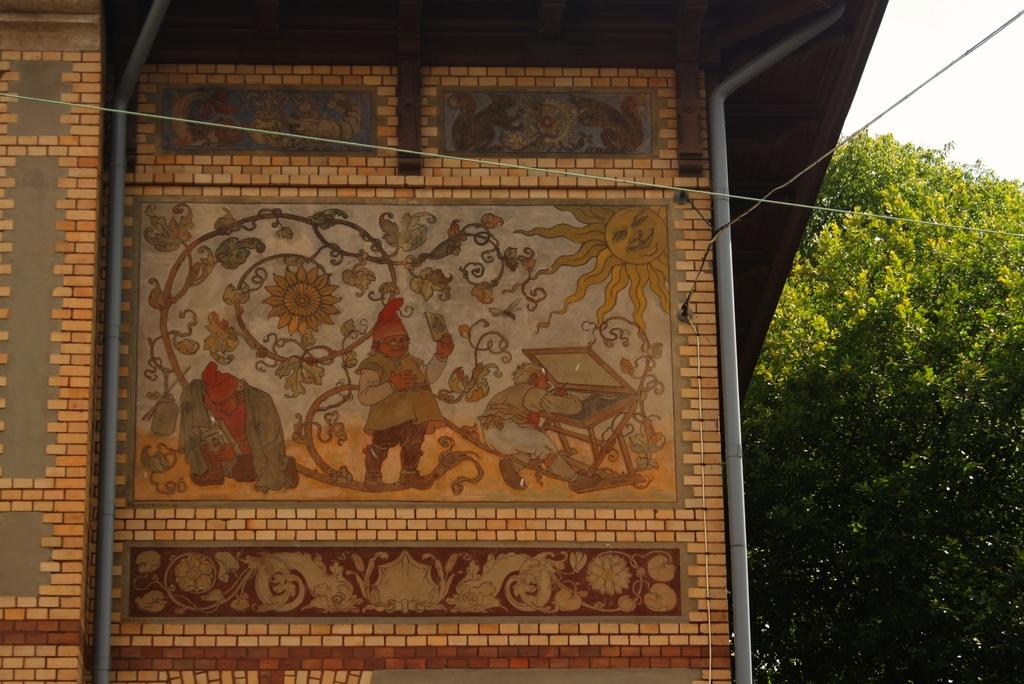What is the main subject of the image? The main subject of the image is a house wall. What is depicted on the house wall? The house wall has arts and paintings on it. What is located near the house wall? There is a tree beside the house wall. What can be seen in the background of the image? The sky is partially visible in the image. What type of string is used to hang the paintings on the house wall in the image? There is no information about the type of string used to hang the paintings on the house wall in the image. In fact, the image does not show any string at all. 